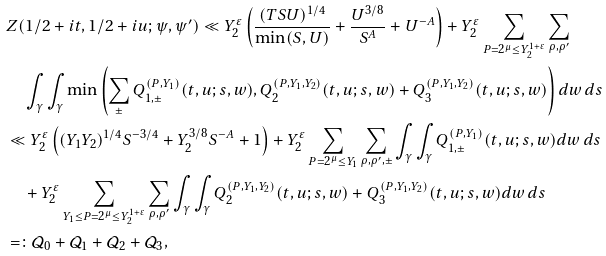Convert formula to latex. <formula><loc_0><loc_0><loc_500><loc_500>& Z ( 1 / 2 + i t , 1 / 2 + i u ; \psi , \psi ^ { \prime } ) \ll Y _ { 2 } ^ { \varepsilon } \left ( \frac { ( T S U ) ^ { 1 / 4 } } { \min ( S , U ) } + \frac { U ^ { 3 / 8 } } { S ^ { A } } + U ^ { - A } \right ) + Y _ { 2 } ^ { \varepsilon } \sum _ { P = 2 ^ { \mu } \leq Y _ { 2 } ^ { 1 + \varepsilon } } \sum _ { \rho , \rho ^ { \prime } } \\ & \quad \int _ { \gamma } \int _ { \gamma } \min \left ( \sum _ { \pm } Q ^ { ( P , Y _ { 1 } ) } _ { 1 , \pm } ( t , u ; s , w ) , Q _ { 2 } ^ { ( P , Y _ { 1 } , Y _ { 2 } ) } ( t , u ; s , w ) + Q _ { 3 } ^ { ( P , Y _ { 1 } , Y _ { 2 } ) } ( t , u ; s , w ) \right ) d w \, d s \\ & \ll Y _ { 2 } ^ { \varepsilon } \left ( ( Y _ { 1 } Y _ { 2 } ) ^ { 1 / 4 } S ^ { - 3 / 4 } + Y _ { 2 } ^ { 3 / 8 } { S ^ { - A } } + 1 \right ) + Y _ { 2 } ^ { \varepsilon } \sum _ { P = 2 ^ { \mu } \leq Y _ { 1 } } \sum _ { \rho , \rho ^ { \prime } , \pm } \int _ { \gamma } \int _ { \gamma } Q ^ { ( P , Y _ { 1 } ) } _ { 1 , \pm } ( t , u ; s , w ) d w \, d s \\ & \quad + Y _ { 2 } ^ { \varepsilon } \sum _ { Y _ { 1 } \leq P = 2 ^ { \mu } \leq Y _ { 2 } ^ { 1 + \varepsilon } } \sum _ { \rho , \rho ^ { \prime } } \int _ { \gamma } \int _ { \gamma } Q _ { 2 } ^ { ( P , Y _ { 1 } , Y _ { 2 } ) } ( t , u ; s , w ) + Q _ { 3 } ^ { ( P , Y _ { 1 } , Y _ { 2 } ) } ( t , u ; s , w ) d w \, d s \\ & = \colon \mathcal { Q } _ { 0 } + \mathcal { Q } _ { 1 } + \mathcal { Q } _ { 2 } + \mathcal { Q } _ { 3 } ,</formula> 